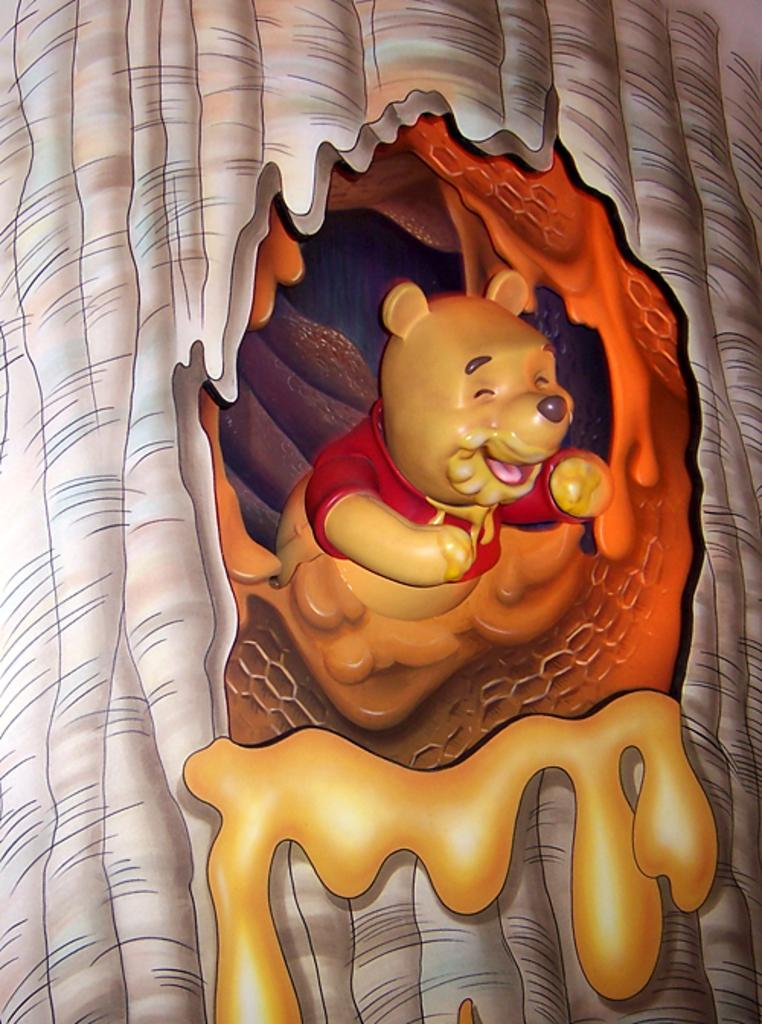What is located in the foreground of the image? There is a teddy bear and a tree trunk in the foreground of the image. Can you describe the setting of the image? The image may have been taken in a house. What type of smile can be seen on the teddy bear's face in the image? There is no smile on the teddy bear's face in the image, as teddy bears do not have facial expressions. 